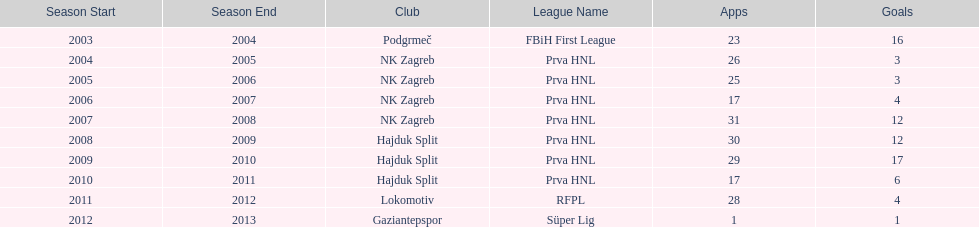What were the names of each club where more than 15 goals were scored in a single season? Podgrmeč, Hajduk Split. 